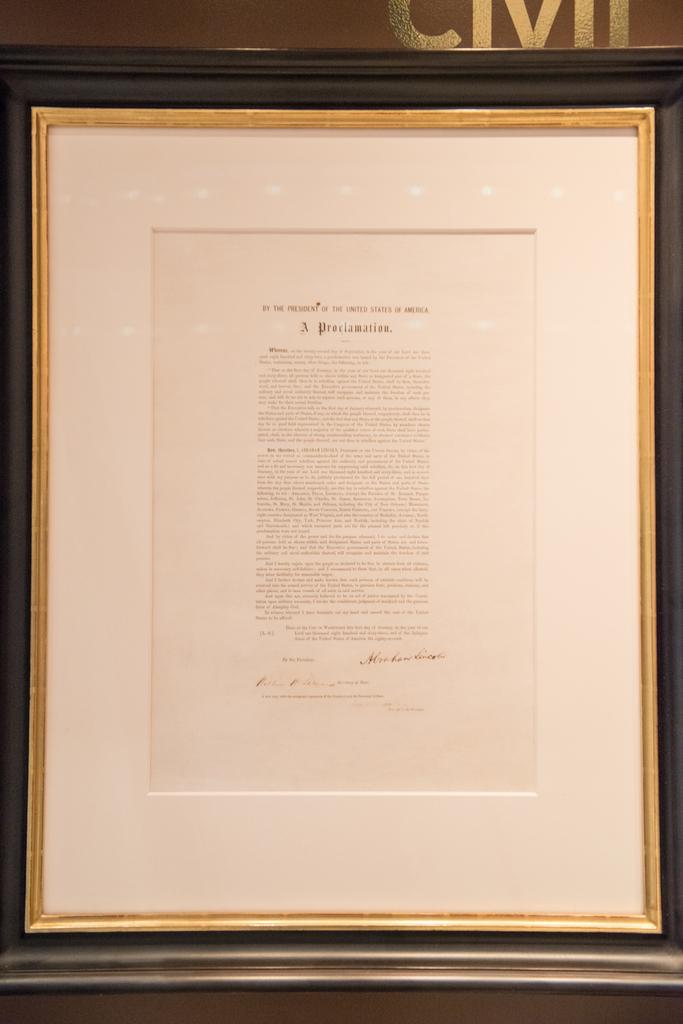What kind of document is this?
Ensure brevity in your answer.  Proclamation . 